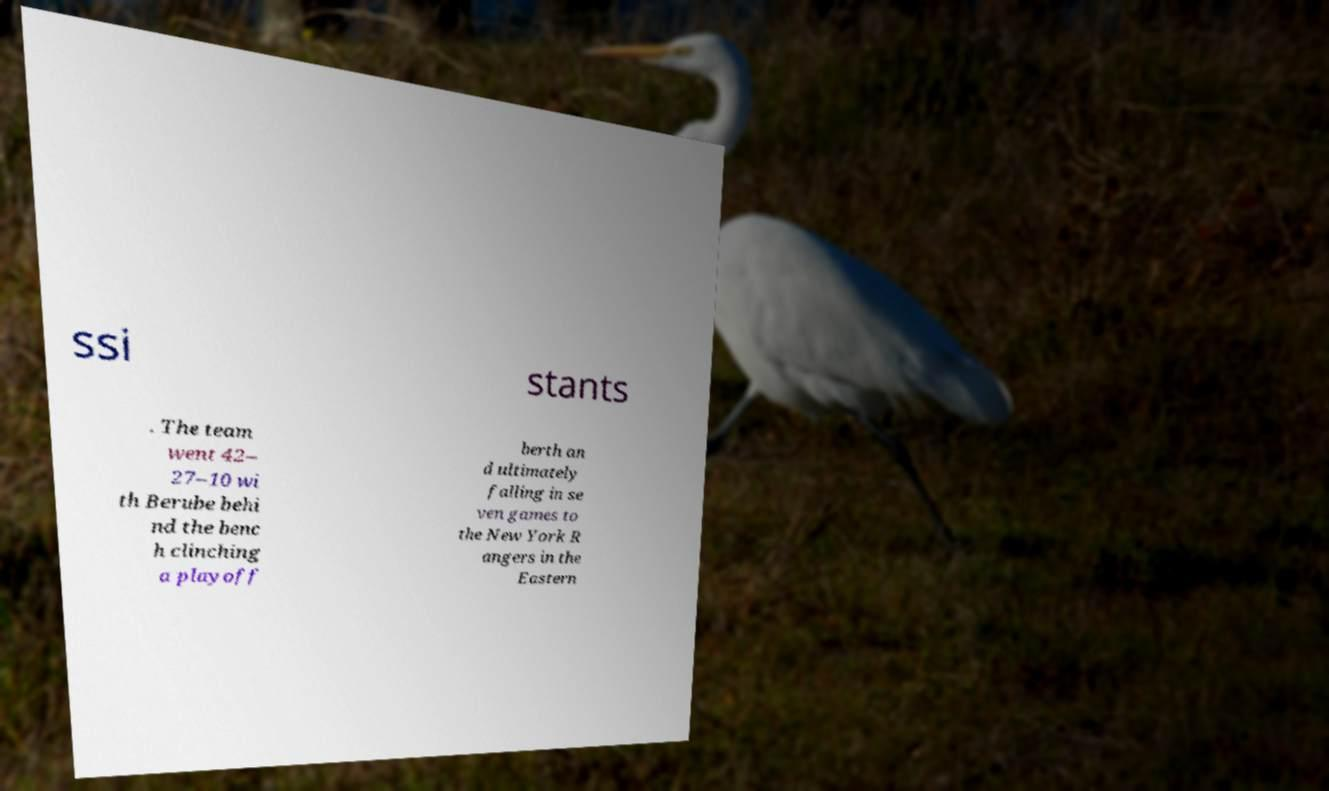Could you assist in decoding the text presented in this image and type it out clearly? ssi stants . The team went 42– 27–10 wi th Berube behi nd the benc h clinching a playoff berth an d ultimately falling in se ven games to the New York R angers in the Eastern 